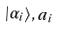<formula> <loc_0><loc_0><loc_500><loc_500>| \alpha _ { i } \rangle , a _ { i }</formula> 